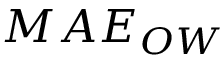Convert formula to latex. <formula><loc_0><loc_0><loc_500><loc_500>M A E _ { O W }</formula> 